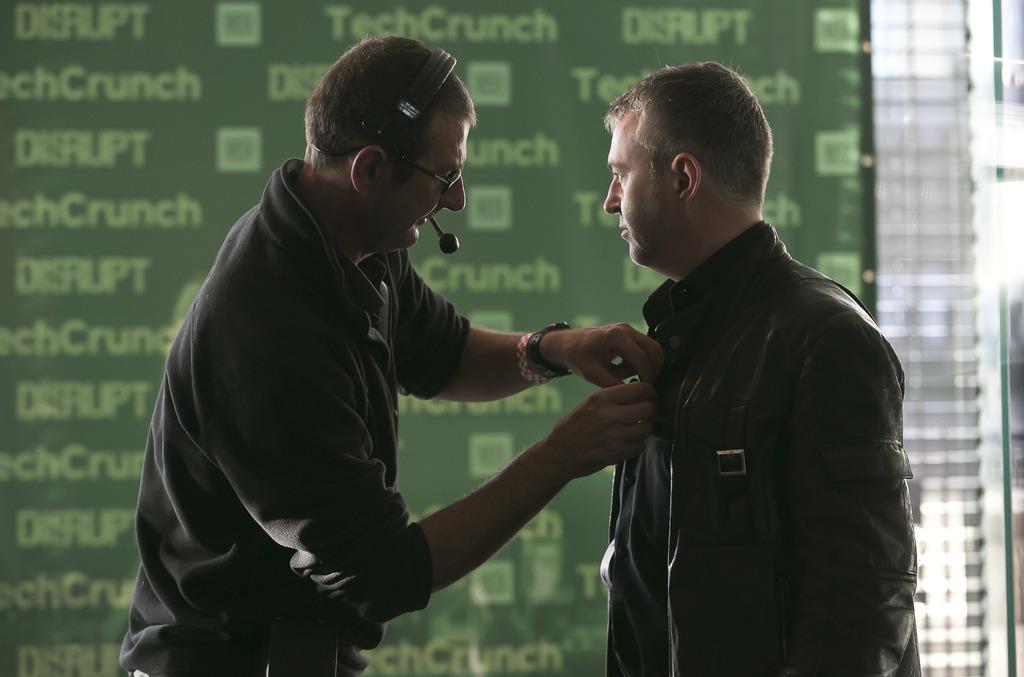Could you give a brief overview of what you see in this image? In this image, we can see persons wearing clothes in front of sponsor board. 